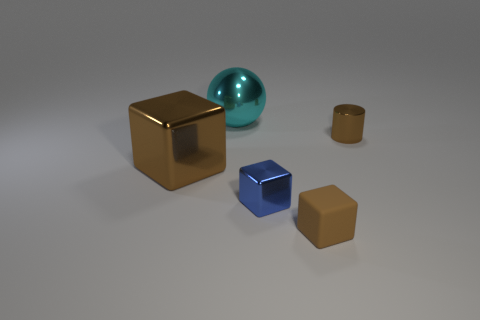Add 3 big metal things. How many objects exist? 8 Subtract all cubes. How many objects are left? 2 Add 1 small brown metallic objects. How many small brown metallic objects exist? 2 Subtract 0 cyan cylinders. How many objects are left? 5 Subtract all big brown rubber balls. Subtract all small brown blocks. How many objects are left? 4 Add 1 big metal objects. How many big metal objects are left? 3 